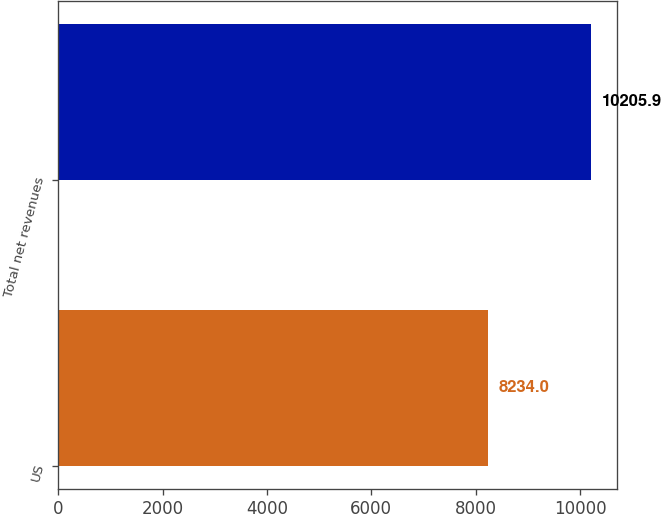<chart> <loc_0><loc_0><loc_500><loc_500><bar_chart><fcel>US<fcel>Total net revenues<nl><fcel>8234<fcel>10205.9<nl></chart> 